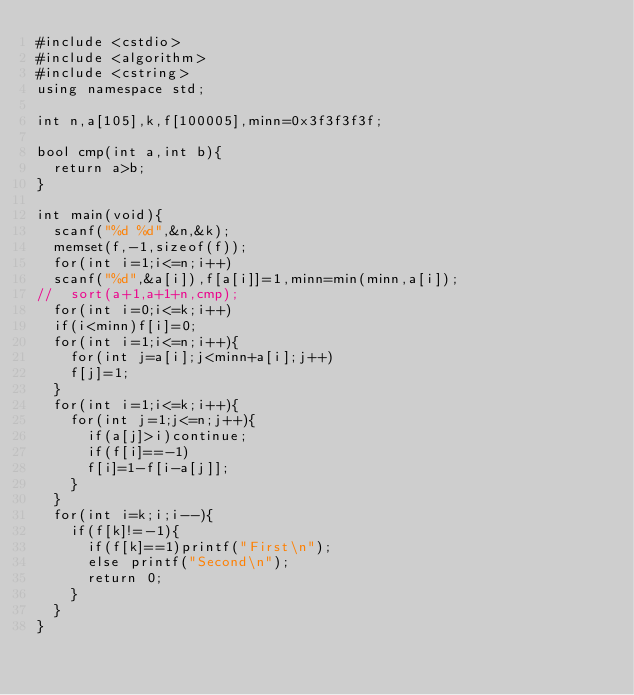Convert code to text. <code><loc_0><loc_0><loc_500><loc_500><_C++_>#include <cstdio>
#include <algorithm>
#include <cstring>
using namespace std;

int n,a[105],k,f[100005],minn=0x3f3f3f3f;

bool cmp(int a,int b){
	return a>b;
}

int main(void){
	scanf("%d %d",&n,&k);
	memset(f,-1,sizeof(f));
	for(int i=1;i<=n;i++)
	scanf("%d",&a[i]),f[a[i]]=1,minn=min(minn,a[i]);
//	sort(a+1,a+1+n,cmp);
	for(int i=0;i<=k;i++)
	if(i<minn)f[i]=0;
	for(int i=1;i<=n;i++){
		for(int j=a[i];j<minn+a[i];j++)
		f[j]=1;
	}
	for(int i=1;i<=k;i++){
		for(int j=1;j<=n;j++){
			if(a[j]>i)continue;
			if(f[i]==-1)
			f[i]=1-f[i-a[j]];
		}
	}
	for(int i=k;i;i--){
		if(f[k]!=-1){
			if(f[k]==1)printf("First\n");
			else printf("Second\n");
			return 0;
		} 
	} 
}
</code> 